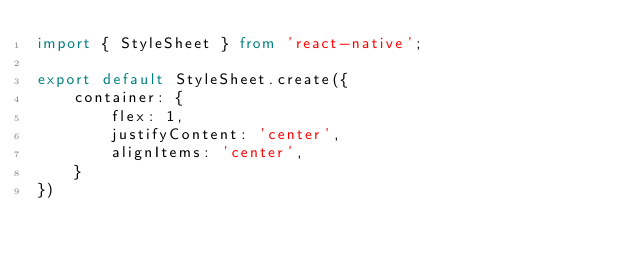Convert code to text. <code><loc_0><loc_0><loc_500><loc_500><_TypeScript_>import { StyleSheet } from 'react-native';

export default StyleSheet.create({
    container: {
        flex: 1,
        justifyContent: 'center',
        alignItems: 'center',
    }
})</code> 